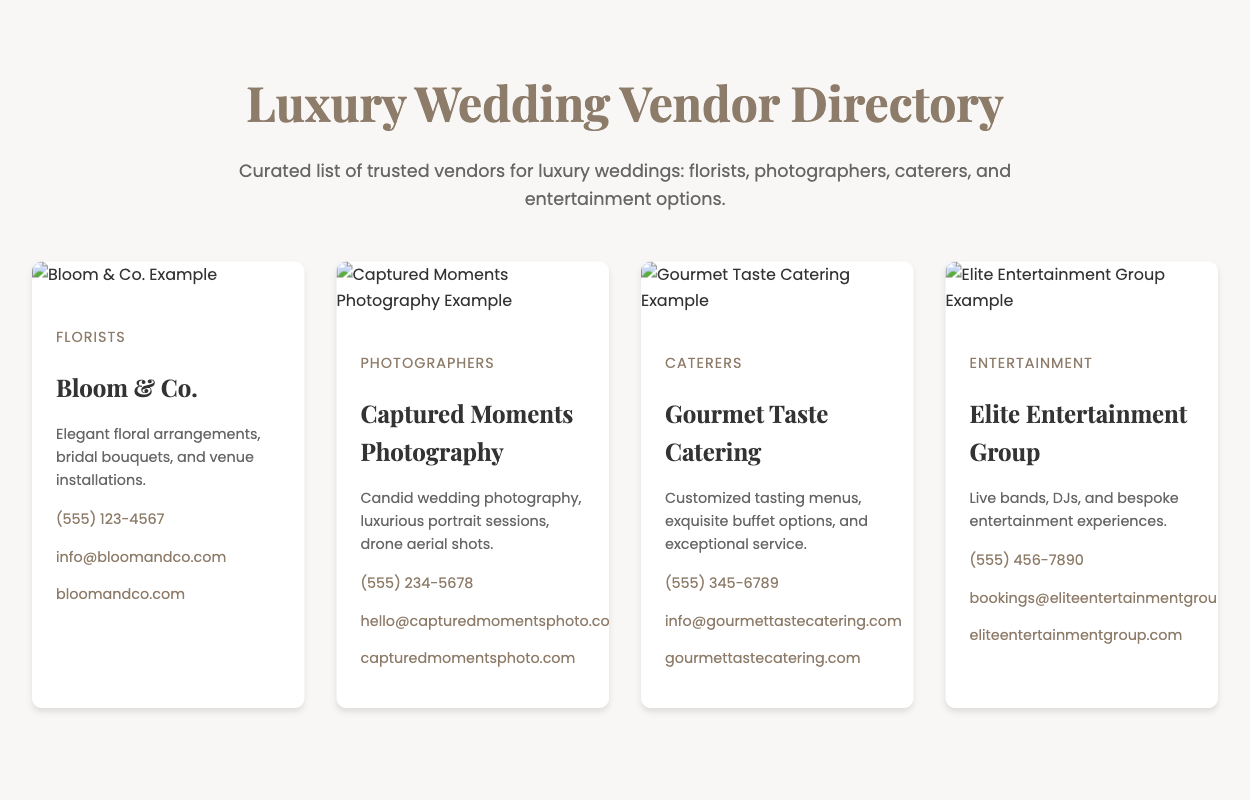What is the name of the florist? The florist listed in the directory is Bloom & Co.
Answer: Bloom & Co What services does Gourmet Taste Catering provide? Gourmet Taste Catering specializes in customized tasting menus, exquisite buffet options, and exceptional service.
Answer: Customized tasting menus What contact method is provided for Captured Moments Photography? Captured Moments Photography provides a phone number, email, and website for contact.
Answer: (555) 234-5678 Who offers live bands and DJs? Elite Entertainment Group is the vendor that offers live bands and DJs.
Answer: Elite Entertainment Group What is the category of Bloom & Co.? Bloom & Co. is categorized under florists.
Answer: Florists Which vendor specializes in drone aerial shots? Captured Moments Photography specializes in drone aerial shots.
Answer: Captured Moments Photography How many types of vendors are listed in the directory? The directory lists four types of vendors: florists, photographers, caterers, and entertainment options.
Answer: Four What is the website of Gourmet Taste Catering? The website provided for Gourmet Taste Catering is gourmettastecatering.com.
Answer: gourmettastecatering.com 